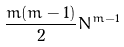<formula> <loc_0><loc_0><loc_500><loc_500>\frac { m ( m - 1 ) } { 2 } { \bar { N } } ^ { m - 1 }</formula> 